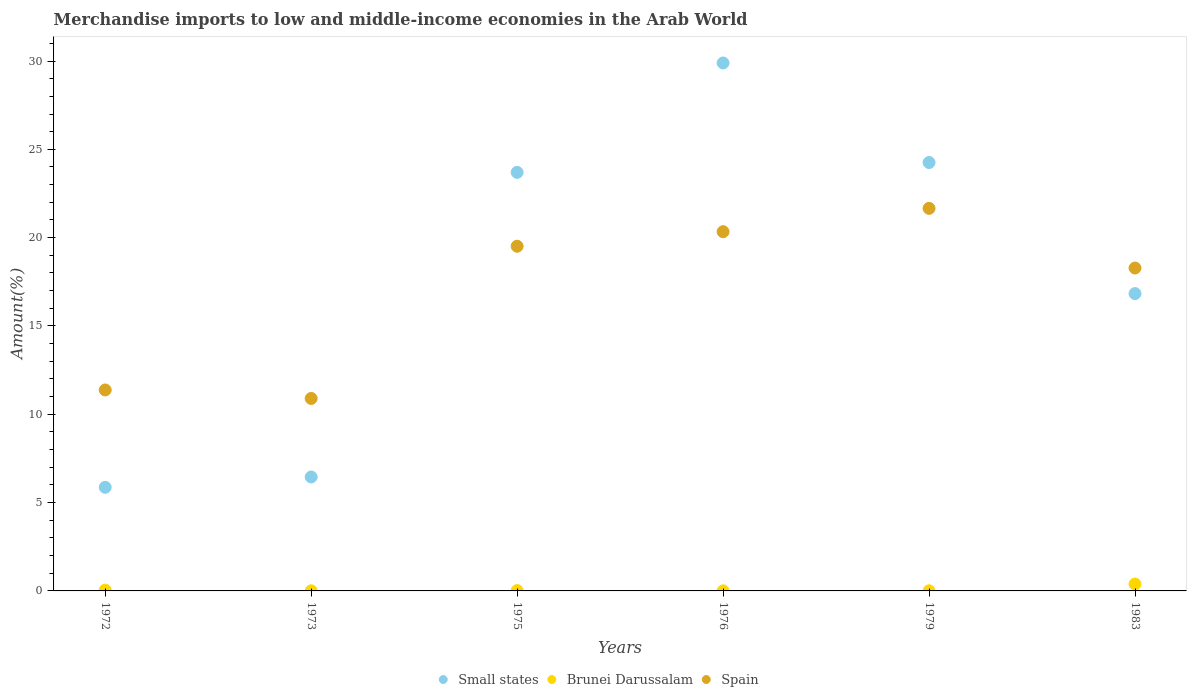Is the number of dotlines equal to the number of legend labels?
Ensure brevity in your answer.  Yes. What is the percentage of amount earned from merchandise imports in Brunei Darussalam in 1975?
Your answer should be compact. 0.02. Across all years, what is the maximum percentage of amount earned from merchandise imports in Brunei Darussalam?
Keep it short and to the point. 0.39. Across all years, what is the minimum percentage of amount earned from merchandise imports in Spain?
Your answer should be compact. 10.9. In which year was the percentage of amount earned from merchandise imports in Spain maximum?
Ensure brevity in your answer.  1979. In which year was the percentage of amount earned from merchandise imports in Small states minimum?
Your answer should be compact. 1972. What is the total percentage of amount earned from merchandise imports in Small states in the graph?
Ensure brevity in your answer.  106.99. What is the difference between the percentage of amount earned from merchandise imports in Brunei Darussalam in 1973 and that in 1975?
Your response must be concise. -0.01. What is the difference between the percentage of amount earned from merchandise imports in Small states in 1975 and the percentage of amount earned from merchandise imports in Brunei Darussalam in 1972?
Provide a short and direct response. 23.65. What is the average percentage of amount earned from merchandise imports in Spain per year?
Keep it short and to the point. 17.01. In the year 1972, what is the difference between the percentage of amount earned from merchandise imports in Brunei Darussalam and percentage of amount earned from merchandise imports in Spain?
Provide a short and direct response. -11.33. In how many years, is the percentage of amount earned from merchandise imports in Small states greater than 24 %?
Give a very brief answer. 2. What is the ratio of the percentage of amount earned from merchandise imports in Brunei Darussalam in 1972 to that in 1976?
Make the answer very short. 12.2. Is the difference between the percentage of amount earned from merchandise imports in Brunei Darussalam in 1973 and 1983 greater than the difference between the percentage of amount earned from merchandise imports in Spain in 1973 and 1983?
Offer a very short reply. Yes. What is the difference between the highest and the second highest percentage of amount earned from merchandise imports in Brunei Darussalam?
Make the answer very short. 0.34. What is the difference between the highest and the lowest percentage of amount earned from merchandise imports in Brunei Darussalam?
Your answer should be compact. 0.39. In how many years, is the percentage of amount earned from merchandise imports in Spain greater than the average percentage of amount earned from merchandise imports in Spain taken over all years?
Offer a very short reply. 4. Is the sum of the percentage of amount earned from merchandise imports in Brunei Darussalam in 1973 and 1979 greater than the maximum percentage of amount earned from merchandise imports in Small states across all years?
Give a very brief answer. No. Is it the case that in every year, the sum of the percentage of amount earned from merchandise imports in Small states and percentage of amount earned from merchandise imports in Spain  is greater than the percentage of amount earned from merchandise imports in Brunei Darussalam?
Offer a terse response. Yes. How many years are there in the graph?
Offer a very short reply. 6. Does the graph contain grids?
Give a very brief answer. No. How many legend labels are there?
Your answer should be compact. 3. How are the legend labels stacked?
Provide a short and direct response. Horizontal. What is the title of the graph?
Ensure brevity in your answer.  Merchandise imports to low and middle-income economies in the Arab World. What is the label or title of the Y-axis?
Your answer should be compact. Amount(%). What is the Amount(%) of Small states in 1972?
Your answer should be very brief. 5.87. What is the Amount(%) of Brunei Darussalam in 1972?
Keep it short and to the point. 0.05. What is the Amount(%) of Spain in 1972?
Your answer should be compact. 11.38. What is the Amount(%) of Small states in 1973?
Keep it short and to the point. 6.45. What is the Amount(%) of Brunei Darussalam in 1973?
Provide a short and direct response. 0.01. What is the Amount(%) in Spain in 1973?
Your answer should be very brief. 10.9. What is the Amount(%) in Small states in 1975?
Keep it short and to the point. 23.7. What is the Amount(%) of Brunei Darussalam in 1975?
Offer a terse response. 0.02. What is the Amount(%) of Spain in 1975?
Make the answer very short. 19.51. What is the Amount(%) of Small states in 1976?
Give a very brief answer. 29.89. What is the Amount(%) in Brunei Darussalam in 1976?
Keep it short and to the point. 0. What is the Amount(%) of Spain in 1976?
Ensure brevity in your answer.  20.34. What is the Amount(%) of Small states in 1979?
Provide a succinct answer. 24.25. What is the Amount(%) in Brunei Darussalam in 1979?
Your answer should be very brief. 0.01. What is the Amount(%) in Spain in 1979?
Your answer should be very brief. 21.66. What is the Amount(%) in Small states in 1983?
Keep it short and to the point. 16.83. What is the Amount(%) of Brunei Darussalam in 1983?
Provide a succinct answer. 0.39. What is the Amount(%) in Spain in 1983?
Your answer should be very brief. 18.28. Across all years, what is the maximum Amount(%) of Small states?
Offer a very short reply. 29.89. Across all years, what is the maximum Amount(%) in Brunei Darussalam?
Keep it short and to the point. 0.39. Across all years, what is the maximum Amount(%) in Spain?
Your answer should be compact. 21.66. Across all years, what is the minimum Amount(%) in Small states?
Your answer should be very brief. 5.87. Across all years, what is the minimum Amount(%) of Brunei Darussalam?
Ensure brevity in your answer.  0. Across all years, what is the minimum Amount(%) of Spain?
Provide a short and direct response. 10.9. What is the total Amount(%) in Small states in the graph?
Your response must be concise. 106.99. What is the total Amount(%) in Brunei Darussalam in the graph?
Ensure brevity in your answer.  0.47. What is the total Amount(%) of Spain in the graph?
Your answer should be compact. 102.06. What is the difference between the Amount(%) in Small states in 1972 and that in 1973?
Ensure brevity in your answer.  -0.59. What is the difference between the Amount(%) of Brunei Darussalam in 1972 and that in 1973?
Provide a short and direct response. 0.04. What is the difference between the Amount(%) of Spain in 1972 and that in 1973?
Ensure brevity in your answer.  0.48. What is the difference between the Amount(%) of Small states in 1972 and that in 1975?
Offer a very short reply. -17.83. What is the difference between the Amount(%) in Brunei Darussalam in 1972 and that in 1975?
Your answer should be compact. 0.03. What is the difference between the Amount(%) in Spain in 1972 and that in 1975?
Your answer should be very brief. -8.14. What is the difference between the Amount(%) of Small states in 1972 and that in 1976?
Provide a succinct answer. -24.02. What is the difference between the Amount(%) of Brunei Darussalam in 1972 and that in 1976?
Provide a short and direct response. 0.04. What is the difference between the Amount(%) in Spain in 1972 and that in 1976?
Your answer should be very brief. -8.96. What is the difference between the Amount(%) of Small states in 1972 and that in 1979?
Provide a short and direct response. -18.39. What is the difference between the Amount(%) in Brunei Darussalam in 1972 and that in 1979?
Your answer should be compact. 0.04. What is the difference between the Amount(%) of Spain in 1972 and that in 1979?
Keep it short and to the point. -10.28. What is the difference between the Amount(%) in Small states in 1972 and that in 1983?
Give a very brief answer. -10.97. What is the difference between the Amount(%) of Brunei Darussalam in 1972 and that in 1983?
Make the answer very short. -0.34. What is the difference between the Amount(%) of Spain in 1972 and that in 1983?
Your answer should be very brief. -6.9. What is the difference between the Amount(%) in Small states in 1973 and that in 1975?
Provide a short and direct response. -17.25. What is the difference between the Amount(%) of Brunei Darussalam in 1973 and that in 1975?
Offer a very short reply. -0.01. What is the difference between the Amount(%) in Spain in 1973 and that in 1975?
Offer a terse response. -8.62. What is the difference between the Amount(%) of Small states in 1973 and that in 1976?
Offer a terse response. -23.44. What is the difference between the Amount(%) of Brunei Darussalam in 1973 and that in 1976?
Your answer should be very brief. 0. What is the difference between the Amount(%) in Spain in 1973 and that in 1976?
Keep it short and to the point. -9.44. What is the difference between the Amount(%) of Small states in 1973 and that in 1979?
Offer a very short reply. -17.8. What is the difference between the Amount(%) in Brunei Darussalam in 1973 and that in 1979?
Keep it short and to the point. -0. What is the difference between the Amount(%) in Spain in 1973 and that in 1979?
Keep it short and to the point. -10.76. What is the difference between the Amount(%) of Small states in 1973 and that in 1983?
Your response must be concise. -10.38. What is the difference between the Amount(%) of Brunei Darussalam in 1973 and that in 1983?
Your answer should be very brief. -0.38. What is the difference between the Amount(%) in Spain in 1973 and that in 1983?
Your response must be concise. -7.38. What is the difference between the Amount(%) in Small states in 1975 and that in 1976?
Offer a very short reply. -6.19. What is the difference between the Amount(%) in Brunei Darussalam in 1975 and that in 1976?
Make the answer very short. 0.01. What is the difference between the Amount(%) in Spain in 1975 and that in 1976?
Ensure brevity in your answer.  -0.82. What is the difference between the Amount(%) of Small states in 1975 and that in 1979?
Provide a succinct answer. -0.56. What is the difference between the Amount(%) in Brunei Darussalam in 1975 and that in 1979?
Keep it short and to the point. 0.01. What is the difference between the Amount(%) in Spain in 1975 and that in 1979?
Provide a succinct answer. -2.14. What is the difference between the Amount(%) in Small states in 1975 and that in 1983?
Offer a very short reply. 6.86. What is the difference between the Amount(%) in Brunei Darussalam in 1975 and that in 1983?
Give a very brief answer. -0.37. What is the difference between the Amount(%) of Spain in 1975 and that in 1983?
Keep it short and to the point. 1.23. What is the difference between the Amount(%) in Small states in 1976 and that in 1979?
Offer a very short reply. 5.64. What is the difference between the Amount(%) in Brunei Darussalam in 1976 and that in 1979?
Offer a very short reply. -0. What is the difference between the Amount(%) in Spain in 1976 and that in 1979?
Make the answer very short. -1.32. What is the difference between the Amount(%) in Small states in 1976 and that in 1983?
Give a very brief answer. 13.06. What is the difference between the Amount(%) of Brunei Darussalam in 1976 and that in 1983?
Offer a terse response. -0.39. What is the difference between the Amount(%) of Spain in 1976 and that in 1983?
Offer a terse response. 2.06. What is the difference between the Amount(%) of Small states in 1979 and that in 1983?
Provide a succinct answer. 7.42. What is the difference between the Amount(%) of Brunei Darussalam in 1979 and that in 1983?
Your answer should be compact. -0.38. What is the difference between the Amount(%) in Spain in 1979 and that in 1983?
Give a very brief answer. 3.38. What is the difference between the Amount(%) of Small states in 1972 and the Amount(%) of Brunei Darussalam in 1973?
Make the answer very short. 5.86. What is the difference between the Amount(%) of Small states in 1972 and the Amount(%) of Spain in 1973?
Your response must be concise. -5.03. What is the difference between the Amount(%) of Brunei Darussalam in 1972 and the Amount(%) of Spain in 1973?
Make the answer very short. -10.85. What is the difference between the Amount(%) of Small states in 1972 and the Amount(%) of Brunei Darussalam in 1975?
Ensure brevity in your answer.  5.85. What is the difference between the Amount(%) of Small states in 1972 and the Amount(%) of Spain in 1975?
Offer a very short reply. -13.65. What is the difference between the Amount(%) in Brunei Darussalam in 1972 and the Amount(%) in Spain in 1975?
Keep it short and to the point. -19.47. What is the difference between the Amount(%) in Small states in 1972 and the Amount(%) in Brunei Darussalam in 1976?
Keep it short and to the point. 5.86. What is the difference between the Amount(%) of Small states in 1972 and the Amount(%) of Spain in 1976?
Give a very brief answer. -14.47. What is the difference between the Amount(%) of Brunei Darussalam in 1972 and the Amount(%) of Spain in 1976?
Offer a very short reply. -20.29. What is the difference between the Amount(%) in Small states in 1972 and the Amount(%) in Brunei Darussalam in 1979?
Your answer should be very brief. 5.86. What is the difference between the Amount(%) of Small states in 1972 and the Amount(%) of Spain in 1979?
Give a very brief answer. -15.79. What is the difference between the Amount(%) in Brunei Darussalam in 1972 and the Amount(%) in Spain in 1979?
Your answer should be compact. -21.61. What is the difference between the Amount(%) of Small states in 1972 and the Amount(%) of Brunei Darussalam in 1983?
Your answer should be compact. 5.48. What is the difference between the Amount(%) of Small states in 1972 and the Amount(%) of Spain in 1983?
Keep it short and to the point. -12.41. What is the difference between the Amount(%) of Brunei Darussalam in 1972 and the Amount(%) of Spain in 1983?
Your answer should be very brief. -18.23. What is the difference between the Amount(%) in Small states in 1973 and the Amount(%) in Brunei Darussalam in 1975?
Provide a short and direct response. 6.43. What is the difference between the Amount(%) in Small states in 1973 and the Amount(%) in Spain in 1975?
Ensure brevity in your answer.  -13.06. What is the difference between the Amount(%) of Brunei Darussalam in 1973 and the Amount(%) of Spain in 1975?
Ensure brevity in your answer.  -19.51. What is the difference between the Amount(%) in Small states in 1973 and the Amount(%) in Brunei Darussalam in 1976?
Offer a very short reply. 6.45. What is the difference between the Amount(%) in Small states in 1973 and the Amount(%) in Spain in 1976?
Give a very brief answer. -13.89. What is the difference between the Amount(%) in Brunei Darussalam in 1973 and the Amount(%) in Spain in 1976?
Provide a succinct answer. -20.33. What is the difference between the Amount(%) in Small states in 1973 and the Amount(%) in Brunei Darussalam in 1979?
Provide a succinct answer. 6.44. What is the difference between the Amount(%) in Small states in 1973 and the Amount(%) in Spain in 1979?
Make the answer very short. -15.21. What is the difference between the Amount(%) in Brunei Darussalam in 1973 and the Amount(%) in Spain in 1979?
Keep it short and to the point. -21.65. What is the difference between the Amount(%) of Small states in 1973 and the Amount(%) of Brunei Darussalam in 1983?
Provide a short and direct response. 6.06. What is the difference between the Amount(%) in Small states in 1973 and the Amount(%) in Spain in 1983?
Your answer should be compact. -11.83. What is the difference between the Amount(%) of Brunei Darussalam in 1973 and the Amount(%) of Spain in 1983?
Your response must be concise. -18.27. What is the difference between the Amount(%) in Small states in 1975 and the Amount(%) in Brunei Darussalam in 1976?
Make the answer very short. 23.69. What is the difference between the Amount(%) in Small states in 1975 and the Amount(%) in Spain in 1976?
Provide a succinct answer. 3.36. What is the difference between the Amount(%) in Brunei Darussalam in 1975 and the Amount(%) in Spain in 1976?
Make the answer very short. -20.32. What is the difference between the Amount(%) of Small states in 1975 and the Amount(%) of Brunei Darussalam in 1979?
Make the answer very short. 23.69. What is the difference between the Amount(%) in Small states in 1975 and the Amount(%) in Spain in 1979?
Your answer should be very brief. 2.04. What is the difference between the Amount(%) in Brunei Darussalam in 1975 and the Amount(%) in Spain in 1979?
Provide a succinct answer. -21.64. What is the difference between the Amount(%) in Small states in 1975 and the Amount(%) in Brunei Darussalam in 1983?
Your answer should be very brief. 23.31. What is the difference between the Amount(%) in Small states in 1975 and the Amount(%) in Spain in 1983?
Provide a short and direct response. 5.42. What is the difference between the Amount(%) in Brunei Darussalam in 1975 and the Amount(%) in Spain in 1983?
Give a very brief answer. -18.26. What is the difference between the Amount(%) of Small states in 1976 and the Amount(%) of Brunei Darussalam in 1979?
Make the answer very short. 29.88. What is the difference between the Amount(%) of Small states in 1976 and the Amount(%) of Spain in 1979?
Offer a terse response. 8.23. What is the difference between the Amount(%) in Brunei Darussalam in 1976 and the Amount(%) in Spain in 1979?
Your answer should be compact. -21.65. What is the difference between the Amount(%) in Small states in 1976 and the Amount(%) in Brunei Darussalam in 1983?
Your response must be concise. 29.5. What is the difference between the Amount(%) of Small states in 1976 and the Amount(%) of Spain in 1983?
Make the answer very short. 11.61. What is the difference between the Amount(%) of Brunei Darussalam in 1976 and the Amount(%) of Spain in 1983?
Provide a short and direct response. -18.28. What is the difference between the Amount(%) in Small states in 1979 and the Amount(%) in Brunei Darussalam in 1983?
Make the answer very short. 23.86. What is the difference between the Amount(%) in Small states in 1979 and the Amount(%) in Spain in 1983?
Provide a succinct answer. 5.97. What is the difference between the Amount(%) of Brunei Darussalam in 1979 and the Amount(%) of Spain in 1983?
Provide a succinct answer. -18.27. What is the average Amount(%) in Small states per year?
Your answer should be compact. 17.83. What is the average Amount(%) in Brunei Darussalam per year?
Your answer should be compact. 0.08. What is the average Amount(%) in Spain per year?
Give a very brief answer. 17.01. In the year 1972, what is the difference between the Amount(%) in Small states and Amount(%) in Brunei Darussalam?
Offer a terse response. 5.82. In the year 1972, what is the difference between the Amount(%) in Small states and Amount(%) in Spain?
Offer a very short reply. -5.51. In the year 1972, what is the difference between the Amount(%) in Brunei Darussalam and Amount(%) in Spain?
Offer a terse response. -11.33. In the year 1973, what is the difference between the Amount(%) in Small states and Amount(%) in Brunei Darussalam?
Provide a short and direct response. 6.44. In the year 1973, what is the difference between the Amount(%) of Small states and Amount(%) of Spain?
Offer a very short reply. -4.45. In the year 1973, what is the difference between the Amount(%) in Brunei Darussalam and Amount(%) in Spain?
Make the answer very short. -10.89. In the year 1975, what is the difference between the Amount(%) of Small states and Amount(%) of Brunei Darussalam?
Your answer should be compact. 23.68. In the year 1975, what is the difference between the Amount(%) in Small states and Amount(%) in Spain?
Offer a terse response. 4.18. In the year 1975, what is the difference between the Amount(%) in Brunei Darussalam and Amount(%) in Spain?
Ensure brevity in your answer.  -19.5. In the year 1976, what is the difference between the Amount(%) in Small states and Amount(%) in Brunei Darussalam?
Your response must be concise. 29.89. In the year 1976, what is the difference between the Amount(%) of Small states and Amount(%) of Spain?
Your answer should be very brief. 9.55. In the year 1976, what is the difference between the Amount(%) in Brunei Darussalam and Amount(%) in Spain?
Ensure brevity in your answer.  -20.33. In the year 1979, what is the difference between the Amount(%) of Small states and Amount(%) of Brunei Darussalam?
Offer a very short reply. 24.25. In the year 1979, what is the difference between the Amount(%) in Small states and Amount(%) in Spain?
Provide a succinct answer. 2.6. In the year 1979, what is the difference between the Amount(%) of Brunei Darussalam and Amount(%) of Spain?
Your answer should be very brief. -21.65. In the year 1983, what is the difference between the Amount(%) of Small states and Amount(%) of Brunei Darussalam?
Ensure brevity in your answer.  16.44. In the year 1983, what is the difference between the Amount(%) in Small states and Amount(%) in Spain?
Your response must be concise. -1.45. In the year 1983, what is the difference between the Amount(%) of Brunei Darussalam and Amount(%) of Spain?
Provide a short and direct response. -17.89. What is the ratio of the Amount(%) of Small states in 1972 to that in 1973?
Provide a succinct answer. 0.91. What is the ratio of the Amount(%) of Brunei Darussalam in 1972 to that in 1973?
Give a very brief answer. 6.21. What is the ratio of the Amount(%) of Spain in 1972 to that in 1973?
Offer a very short reply. 1.04. What is the ratio of the Amount(%) of Small states in 1972 to that in 1975?
Provide a short and direct response. 0.25. What is the ratio of the Amount(%) in Brunei Darussalam in 1972 to that in 1975?
Keep it short and to the point. 2.56. What is the ratio of the Amount(%) of Spain in 1972 to that in 1975?
Your answer should be very brief. 0.58. What is the ratio of the Amount(%) in Small states in 1972 to that in 1976?
Offer a very short reply. 0.2. What is the ratio of the Amount(%) of Brunei Darussalam in 1972 to that in 1976?
Your answer should be very brief. 12.21. What is the ratio of the Amount(%) in Spain in 1972 to that in 1976?
Your answer should be compact. 0.56. What is the ratio of the Amount(%) of Small states in 1972 to that in 1979?
Offer a very short reply. 0.24. What is the ratio of the Amount(%) in Brunei Darussalam in 1972 to that in 1979?
Provide a succinct answer. 6.2. What is the ratio of the Amount(%) in Spain in 1972 to that in 1979?
Provide a short and direct response. 0.53. What is the ratio of the Amount(%) of Small states in 1972 to that in 1983?
Your response must be concise. 0.35. What is the ratio of the Amount(%) in Brunei Darussalam in 1972 to that in 1983?
Offer a very short reply. 0.12. What is the ratio of the Amount(%) of Spain in 1972 to that in 1983?
Make the answer very short. 0.62. What is the ratio of the Amount(%) in Small states in 1973 to that in 1975?
Keep it short and to the point. 0.27. What is the ratio of the Amount(%) of Brunei Darussalam in 1973 to that in 1975?
Your answer should be very brief. 0.41. What is the ratio of the Amount(%) of Spain in 1973 to that in 1975?
Your answer should be compact. 0.56. What is the ratio of the Amount(%) of Small states in 1973 to that in 1976?
Offer a very short reply. 0.22. What is the ratio of the Amount(%) of Brunei Darussalam in 1973 to that in 1976?
Offer a terse response. 1.97. What is the ratio of the Amount(%) in Spain in 1973 to that in 1976?
Provide a succinct answer. 0.54. What is the ratio of the Amount(%) in Small states in 1973 to that in 1979?
Offer a very short reply. 0.27. What is the ratio of the Amount(%) of Spain in 1973 to that in 1979?
Keep it short and to the point. 0.5. What is the ratio of the Amount(%) of Small states in 1973 to that in 1983?
Make the answer very short. 0.38. What is the ratio of the Amount(%) in Brunei Darussalam in 1973 to that in 1983?
Keep it short and to the point. 0.02. What is the ratio of the Amount(%) of Spain in 1973 to that in 1983?
Offer a terse response. 0.6. What is the ratio of the Amount(%) of Small states in 1975 to that in 1976?
Offer a terse response. 0.79. What is the ratio of the Amount(%) in Brunei Darussalam in 1975 to that in 1976?
Provide a succinct answer. 4.76. What is the ratio of the Amount(%) in Spain in 1975 to that in 1976?
Provide a short and direct response. 0.96. What is the ratio of the Amount(%) in Brunei Darussalam in 1975 to that in 1979?
Keep it short and to the point. 2.42. What is the ratio of the Amount(%) of Spain in 1975 to that in 1979?
Your answer should be compact. 0.9. What is the ratio of the Amount(%) of Small states in 1975 to that in 1983?
Provide a short and direct response. 1.41. What is the ratio of the Amount(%) in Brunei Darussalam in 1975 to that in 1983?
Give a very brief answer. 0.05. What is the ratio of the Amount(%) in Spain in 1975 to that in 1983?
Keep it short and to the point. 1.07. What is the ratio of the Amount(%) in Small states in 1976 to that in 1979?
Your answer should be very brief. 1.23. What is the ratio of the Amount(%) of Brunei Darussalam in 1976 to that in 1979?
Your answer should be compact. 0.51. What is the ratio of the Amount(%) of Spain in 1976 to that in 1979?
Ensure brevity in your answer.  0.94. What is the ratio of the Amount(%) of Small states in 1976 to that in 1983?
Provide a succinct answer. 1.78. What is the ratio of the Amount(%) in Brunei Darussalam in 1976 to that in 1983?
Your answer should be compact. 0.01. What is the ratio of the Amount(%) in Spain in 1976 to that in 1983?
Your response must be concise. 1.11. What is the ratio of the Amount(%) in Small states in 1979 to that in 1983?
Your answer should be compact. 1.44. What is the ratio of the Amount(%) of Brunei Darussalam in 1979 to that in 1983?
Offer a terse response. 0.02. What is the ratio of the Amount(%) in Spain in 1979 to that in 1983?
Your response must be concise. 1.18. What is the difference between the highest and the second highest Amount(%) in Small states?
Ensure brevity in your answer.  5.64. What is the difference between the highest and the second highest Amount(%) in Brunei Darussalam?
Make the answer very short. 0.34. What is the difference between the highest and the second highest Amount(%) in Spain?
Your answer should be compact. 1.32. What is the difference between the highest and the lowest Amount(%) in Small states?
Keep it short and to the point. 24.02. What is the difference between the highest and the lowest Amount(%) of Brunei Darussalam?
Your response must be concise. 0.39. What is the difference between the highest and the lowest Amount(%) of Spain?
Provide a short and direct response. 10.76. 